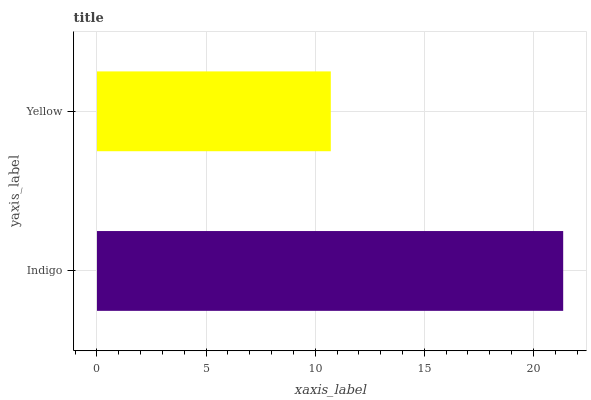Is Yellow the minimum?
Answer yes or no. Yes. Is Indigo the maximum?
Answer yes or no. Yes. Is Yellow the maximum?
Answer yes or no. No. Is Indigo greater than Yellow?
Answer yes or no. Yes. Is Yellow less than Indigo?
Answer yes or no. Yes. Is Yellow greater than Indigo?
Answer yes or no. No. Is Indigo less than Yellow?
Answer yes or no. No. Is Indigo the high median?
Answer yes or no. Yes. Is Yellow the low median?
Answer yes or no. Yes. Is Yellow the high median?
Answer yes or no. No. Is Indigo the low median?
Answer yes or no. No. 